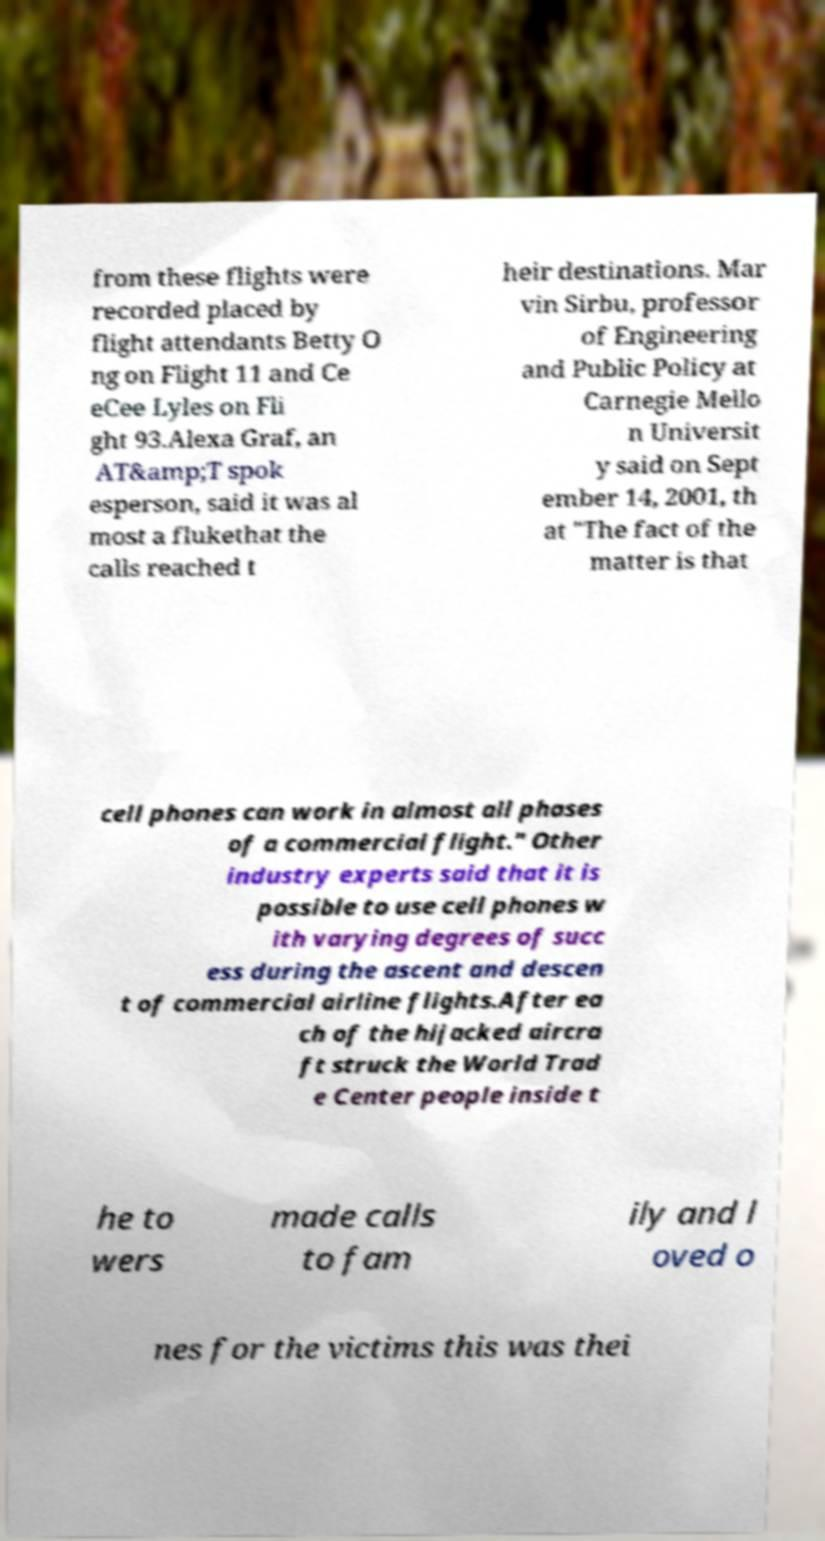Could you extract and type out the text from this image? from these flights were recorded placed by flight attendants Betty O ng on Flight 11 and Ce eCee Lyles on Fli ght 93.Alexa Graf, an AT&amp;T spok esperson, said it was al most a flukethat the calls reached t heir destinations. Mar vin Sirbu, professor of Engineering and Public Policy at Carnegie Mello n Universit y said on Sept ember 14, 2001, th at "The fact of the matter is that cell phones can work in almost all phases of a commercial flight." Other industry experts said that it is possible to use cell phones w ith varying degrees of succ ess during the ascent and descen t of commercial airline flights.After ea ch of the hijacked aircra ft struck the World Trad e Center people inside t he to wers made calls to fam ily and l oved o nes for the victims this was thei 